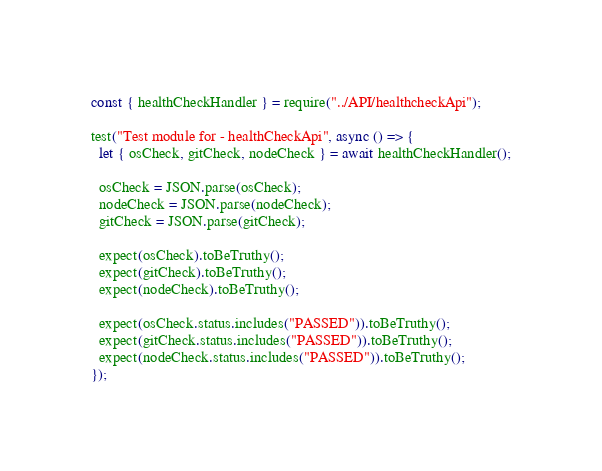<code> <loc_0><loc_0><loc_500><loc_500><_JavaScript_>const { healthCheckHandler } = require("../API/healthcheckApi");

test("Test module for - healthCheckApi", async () => {
  let { osCheck, gitCheck, nodeCheck } = await healthCheckHandler();

  osCheck = JSON.parse(osCheck);
  nodeCheck = JSON.parse(nodeCheck);
  gitCheck = JSON.parse(gitCheck);

  expect(osCheck).toBeTruthy();
  expect(gitCheck).toBeTruthy();
  expect(nodeCheck).toBeTruthy();

  expect(osCheck.status.includes("PASSED")).toBeTruthy();
  expect(gitCheck.status.includes("PASSED")).toBeTruthy();
  expect(nodeCheck.status.includes("PASSED")).toBeTruthy();
});
</code> 